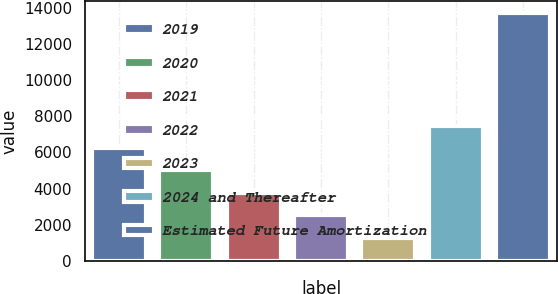Convert chart to OTSL. <chart><loc_0><loc_0><loc_500><loc_500><bar_chart><fcel>2019<fcel>2020<fcel>2021<fcel>2022<fcel>2023<fcel>2024 and Thereafter<fcel>Estimated Future Amortization<nl><fcel>6248.2<fcel>5004.4<fcel>3760.6<fcel>2516.8<fcel>1273<fcel>7492<fcel>13711<nl></chart> 